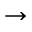<formula> <loc_0><loc_0><loc_500><loc_500>\rightarrow</formula> 